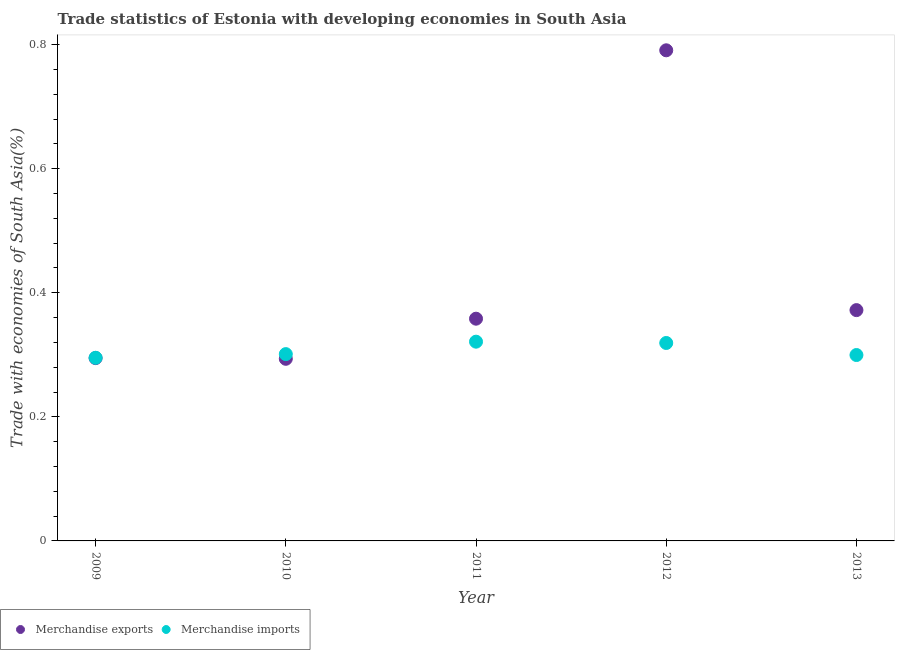How many different coloured dotlines are there?
Keep it short and to the point. 2. What is the merchandise imports in 2010?
Make the answer very short. 0.3. Across all years, what is the maximum merchandise imports?
Your response must be concise. 0.32. Across all years, what is the minimum merchandise imports?
Provide a succinct answer. 0.3. What is the total merchandise exports in the graph?
Keep it short and to the point. 2.11. What is the difference between the merchandise exports in 2011 and that in 2012?
Offer a very short reply. -0.43. What is the difference between the merchandise exports in 2011 and the merchandise imports in 2009?
Provide a succinct answer. 0.06. What is the average merchandise exports per year?
Offer a terse response. 0.42. In the year 2009, what is the difference between the merchandise exports and merchandise imports?
Make the answer very short. -0. In how many years, is the merchandise exports greater than 0.48000000000000004 %?
Your answer should be very brief. 1. What is the ratio of the merchandise imports in 2009 to that in 2010?
Offer a very short reply. 0.98. Is the difference between the merchandise imports in 2010 and 2011 greater than the difference between the merchandise exports in 2010 and 2011?
Offer a very short reply. Yes. What is the difference between the highest and the second highest merchandise imports?
Your answer should be compact. 0. What is the difference between the highest and the lowest merchandise imports?
Offer a terse response. 0.03. Is the sum of the merchandise imports in 2011 and 2013 greater than the maximum merchandise exports across all years?
Give a very brief answer. No. Does the merchandise exports monotonically increase over the years?
Ensure brevity in your answer.  No. Is the merchandise exports strictly greater than the merchandise imports over the years?
Keep it short and to the point. No. Is the merchandise exports strictly less than the merchandise imports over the years?
Provide a succinct answer. No. How many years are there in the graph?
Provide a succinct answer. 5. What is the difference between two consecutive major ticks on the Y-axis?
Your answer should be very brief. 0.2. Does the graph contain any zero values?
Make the answer very short. No. Does the graph contain grids?
Give a very brief answer. No. Where does the legend appear in the graph?
Offer a very short reply. Bottom left. What is the title of the graph?
Offer a terse response. Trade statistics of Estonia with developing economies in South Asia. What is the label or title of the X-axis?
Ensure brevity in your answer.  Year. What is the label or title of the Y-axis?
Your answer should be compact. Trade with economies of South Asia(%). What is the Trade with economies of South Asia(%) in Merchandise exports in 2009?
Give a very brief answer. 0.29. What is the Trade with economies of South Asia(%) in Merchandise imports in 2009?
Provide a succinct answer. 0.3. What is the Trade with economies of South Asia(%) in Merchandise exports in 2010?
Give a very brief answer. 0.29. What is the Trade with economies of South Asia(%) in Merchandise imports in 2010?
Ensure brevity in your answer.  0.3. What is the Trade with economies of South Asia(%) in Merchandise exports in 2011?
Make the answer very short. 0.36. What is the Trade with economies of South Asia(%) in Merchandise imports in 2011?
Offer a very short reply. 0.32. What is the Trade with economies of South Asia(%) of Merchandise exports in 2012?
Offer a very short reply. 0.79. What is the Trade with economies of South Asia(%) in Merchandise imports in 2012?
Provide a succinct answer. 0.32. What is the Trade with economies of South Asia(%) in Merchandise exports in 2013?
Keep it short and to the point. 0.37. What is the Trade with economies of South Asia(%) in Merchandise imports in 2013?
Your answer should be very brief. 0.3. Across all years, what is the maximum Trade with economies of South Asia(%) of Merchandise exports?
Offer a very short reply. 0.79. Across all years, what is the maximum Trade with economies of South Asia(%) in Merchandise imports?
Give a very brief answer. 0.32. Across all years, what is the minimum Trade with economies of South Asia(%) of Merchandise exports?
Keep it short and to the point. 0.29. Across all years, what is the minimum Trade with economies of South Asia(%) in Merchandise imports?
Provide a short and direct response. 0.3. What is the total Trade with economies of South Asia(%) of Merchandise exports in the graph?
Offer a terse response. 2.11. What is the total Trade with economies of South Asia(%) of Merchandise imports in the graph?
Provide a succinct answer. 1.54. What is the difference between the Trade with economies of South Asia(%) of Merchandise exports in 2009 and that in 2010?
Provide a succinct answer. 0. What is the difference between the Trade with economies of South Asia(%) of Merchandise imports in 2009 and that in 2010?
Give a very brief answer. -0.01. What is the difference between the Trade with economies of South Asia(%) in Merchandise exports in 2009 and that in 2011?
Your answer should be very brief. -0.06. What is the difference between the Trade with economies of South Asia(%) of Merchandise imports in 2009 and that in 2011?
Give a very brief answer. -0.03. What is the difference between the Trade with economies of South Asia(%) of Merchandise exports in 2009 and that in 2012?
Ensure brevity in your answer.  -0.5. What is the difference between the Trade with economies of South Asia(%) of Merchandise imports in 2009 and that in 2012?
Make the answer very short. -0.02. What is the difference between the Trade with economies of South Asia(%) in Merchandise exports in 2009 and that in 2013?
Give a very brief answer. -0.08. What is the difference between the Trade with economies of South Asia(%) of Merchandise imports in 2009 and that in 2013?
Ensure brevity in your answer.  -0. What is the difference between the Trade with economies of South Asia(%) of Merchandise exports in 2010 and that in 2011?
Ensure brevity in your answer.  -0.06. What is the difference between the Trade with economies of South Asia(%) of Merchandise imports in 2010 and that in 2011?
Give a very brief answer. -0.02. What is the difference between the Trade with economies of South Asia(%) of Merchandise exports in 2010 and that in 2012?
Keep it short and to the point. -0.5. What is the difference between the Trade with economies of South Asia(%) of Merchandise imports in 2010 and that in 2012?
Keep it short and to the point. -0.02. What is the difference between the Trade with economies of South Asia(%) of Merchandise exports in 2010 and that in 2013?
Offer a very short reply. -0.08. What is the difference between the Trade with economies of South Asia(%) in Merchandise imports in 2010 and that in 2013?
Ensure brevity in your answer.  0. What is the difference between the Trade with economies of South Asia(%) in Merchandise exports in 2011 and that in 2012?
Your answer should be compact. -0.43. What is the difference between the Trade with economies of South Asia(%) in Merchandise imports in 2011 and that in 2012?
Your response must be concise. 0. What is the difference between the Trade with economies of South Asia(%) in Merchandise exports in 2011 and that in 2013?
Offer a very short reply. -0.01. What is the difference between the Trade with economies of South Asia(%) in Merchandise imports in 2011 and that in 2013?
Give a very brief answer. 0.02. What is the difference between the Trade with economies of South Asia(%) in Merchandise exports in 2012 and that in 2013?
Offer a terse response. 0.42. What is the difference between the Trade with economies of South Asia(%) of Merchandise imports in 2012 and that in 2013?
Offer a very short reply. 0.02. What is the difference between the Trade with economies of South Asia(%) of Merchandise exports in 2009 and the Trade with economies of South Asia(%) of Merchandise imports in 2010?
Keep it short and to the point. -0.01. What is the difference between the Trade with economies of South Asia(%) of Merchandise exports in 2009 and the Trade with economies of South Asia(%) of Merchandise imports in 2011?
Offer a terse response. -0.03. What is the difference between the Trade with economies of South Asia(%) of Merchandise exports in 2009 and the Trade with economies of South Asia(%) of Merchandise imports in 2012?
Give a very brief answer. -0.02. What is the difference between the Trade with economies of South Asia(%) in Merchandise exports in 2009 and the Trade with economies of South Asia(%) in Merchandise imports in 2013?
Keep it short and to the point. -0.01. What is the difference between the Trade with economies of South Asia(%) of Merchandise exports in 2010 and the Trade with economies of South Asia(%) of Merchandise imports in 2011?
Provide a short and direct response. -0.03. What is the difference between the Trade with economies of South Asia(%) of Merchandise exports in 2010 and the Trade with economies of South Asia(%) of Merchandise imports in 2012?
Offer a very short reply. -0.03. What is the difference between the Trade with economies of South Asia(%) of Merchandise exports in 2010 and the Trade with economies of South Asia(%) of Merchandise imports in 2013?
Ensure brevity in your answer.  -0.01. What is the difference between the Trade with economies of South Asia(%) in Merchandise exports in 2011 and the Trade with economies of South Asia(%) in Merchandise imports in 2012?
Offer a terse response. 0.04. What is the difference between the Trade with economies of South Asia(%) of Merchandise exports in 2011 and the Trade with economies of South Asia(%) of Merchandise imports in 2013?
Provide a succinct answer. 0.06. What is the difference between the Trade with economies of South Asia(%) of Merchandise exports in 2012 and the Trade with economies of South Asia(%) of Merchandise imports in 2013?
Make the answer very short. 0.49. What is the average Trade with economies of South Asia(%) of Merchandise exports per year?
Make the answer very short. 0.42. What is the average Trade with economies of South Asia(%) in Merchandise imports per year?
Offer a terse response. 0.31. In the year 2009, what is the difference between the Trade with economies of South Asia(%) in Merchandise exports and Trade with economies of South Asia(%) in Merchandise imports?
Make the answer very short. -0. In the year 2010, what is the difference between the Trade with economies of South Asia(%) of Merchandise exports and Trade with economies of South Asia(%) of Merchandise imports?
Offer a terse response. -0.01. In the year 2011, what is the difference between the Trade with economies of South Asia(%) of Merchandise exports and Trade with economies of South Asia(%) of Merchandise imports?
Make the answer very short. 0.04. In the year 2012, what is the difference between the Trade with economies of South Asia(%) in Merchandise exports and Trade with economies of South Asia(%) in Merchandise imports?
Your response must be concise. 0.47. In the year 2013, what is the difference between the Trade with economies of South Asia(%) in Merchandise exports and Trade with economies of South Asia(%) in Merchandise imports?
Your response must be concise. 0.07. What is the ratio of the Trade with economies of South Asia(%) of Merchandise exports in 2009 to that in 2010?
Offer a terse response. 1. What is the ratio of the Trade with economies of South Asia(%) in Merchandise imports in 2009 to that in 2010?
Keep it short and to the point. 0.98. What is the ratio of the Trade with economies of South Asia(%) of Merchandise exports in 2009 to that in 2011?
Give a very brief answer. 0.82. What is the ratio of the Trade with economies of South Asia(%) in Merchandise imports in 2009 to that in 2011?
Your response must be concise. 0.92. What is the ratio of the Trade with economies of South Asia(%) in Merchandise exports in 2009 to that in 2012?
Ensure brevity in your answer.  0.37. What is the ratio of the Trade with economies of South Asia(%) of Merchandise imports in 2009 to that in 2012?
Offer a very short reply. 0.93. What is the ratio of the Trade with economies of South Asia(%) of Merchandise exports in 2009 to that in 2013?
Offer a terse response. 0.79. What is the ratio of the Trade with economies of South Asia(%) in Merchandise imports in 2009 to that in 2013?
Give a very brief answer. 0.99. What is the ratio of the Trade with economies of South Asia(%) in Merchandise exports in 2010 to that in 2011?
Your answer should be compact. 0.82. What is the ratio of the Trade with economies of South Asia(%) in Merchandise imports in 2010 to that in 2011?
Offer a terse response. 0.94. What is the ratio of the Trade with economies of South Asia(%) in Merchandise exports in 2010 to that in 2012?
Keep it short and to the point. 0.37. What is the ratio of the Trade with economies of South Asia(%) in Merchandise imports in 2010 to that in 2012?
Ensure brevity in your answer.  0.94. What is the ratio of the Trade with economies of South Asia(%) of Merchandise exports in 2010 to that in 2013?
Give a very brief answer. 0.79. What is the ratio of the Trade with economies of South Asia(%) in Merchandise exports in 2011 to that in 2012?
Offer a terse response. 0.45. What is the ratio of the Trade with economies of South Asia(%) of Merchandise imports in 2011 to that in 2012?
Offer a very short reply. 1.01. What is the ratio of the Trade with economies of South Asia(%) of Merchandise exports in 2011 to that in 2013?
Your response must be concise. 0.96. What is the ratio of the Trade with economies of South Asia(%) of Merchandise imports in 2011 to that in 2013?
Offer a very short reply. 1.07. What is the ratio of the Trade with economies of South Asia(%) in Merchandise exports in 2012 to that in 2013?
Your answer should be compact. 2.13. What is the ratio of the Trade with economies of South Asia(%) of Merchandise imports in 2012 to that in 2013?
Your answer should be compact. 1.06. What is the difference between the highest and the second highest Trade with economies of South Asia(%) in Merchandise exports?
Ensure brevity in your answer.  0.42. What is the difference between the highest and the second highest Trade with economies of South Asia(%) of Merchandise imports?
Offer a terse response. 0. What is the difference between the highest and the lowest Trade with economies of South Asia(%) in Merchandise exports?
Give a very brief answer. 0.5. What is the difference between the highest and the lowest Trade with economies of South Asia(%) in Merchandise imports?
Offer a very short reply. 0.03. 